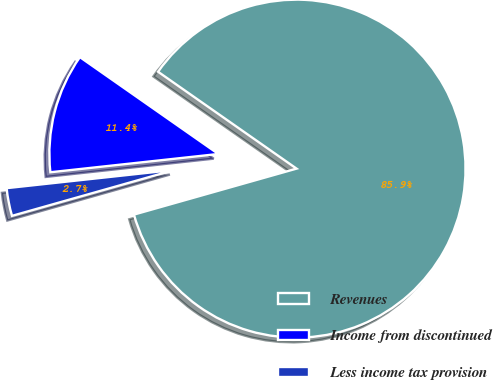Convert chart. <chart><loc_0><loc_0><loc_500><loc_500><pie_chart><fcel>Revenues<fcel>Income from discontinued<fcel>Less income tax provision<nl><fcel>85.9%<fcel>11.44%<fcel>2.66%<nl></chart> 